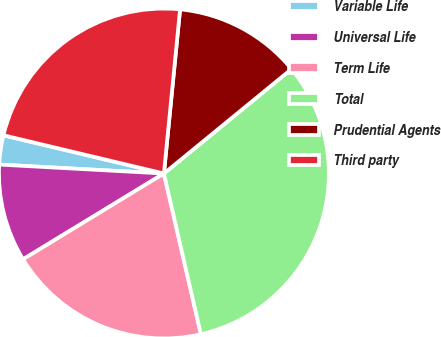Convert chart to OTSL. <chart><loc_0><loc_0><loc_500><loc_500><pie_chart><fcel>Variable Life<fcel>Universal Life<fcel>Term Life<fcel>Total<fcel>Prudential Agents<fcel>Third party<nl><fcel>2.86%<fcel>9.57%<fcel>19.89%<fcel>32.32%<fcel>12.52%<fcel>22.84%<nl></chart> 